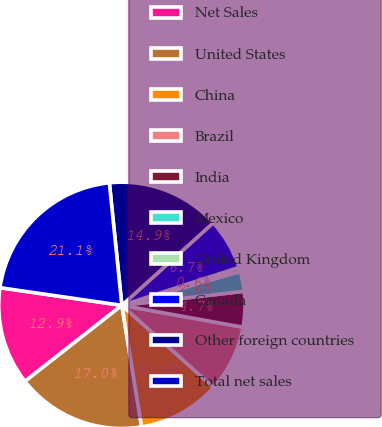Convert chart to OTSL. <chart><loc_0><loc_0><loc_500><loc_500><pie_chart><fcel>Net Sales<fcel>United States<fcel>China<fcel>Brazil<fcel>India<fcel>Mexico<fcel>United Kingdom<fcel>Canada<fcel>Other foreign countries<fcel>Total net sales<nl><fcel>12.88%<fcel>16.98%<fcel>10.82%<fcel>8.77%<fcel>4.66%<fcel>2.61%<fcel>0.55%<fcel>6.71%<fcel>14.93%<fcel>21.09%<nl></chart> 